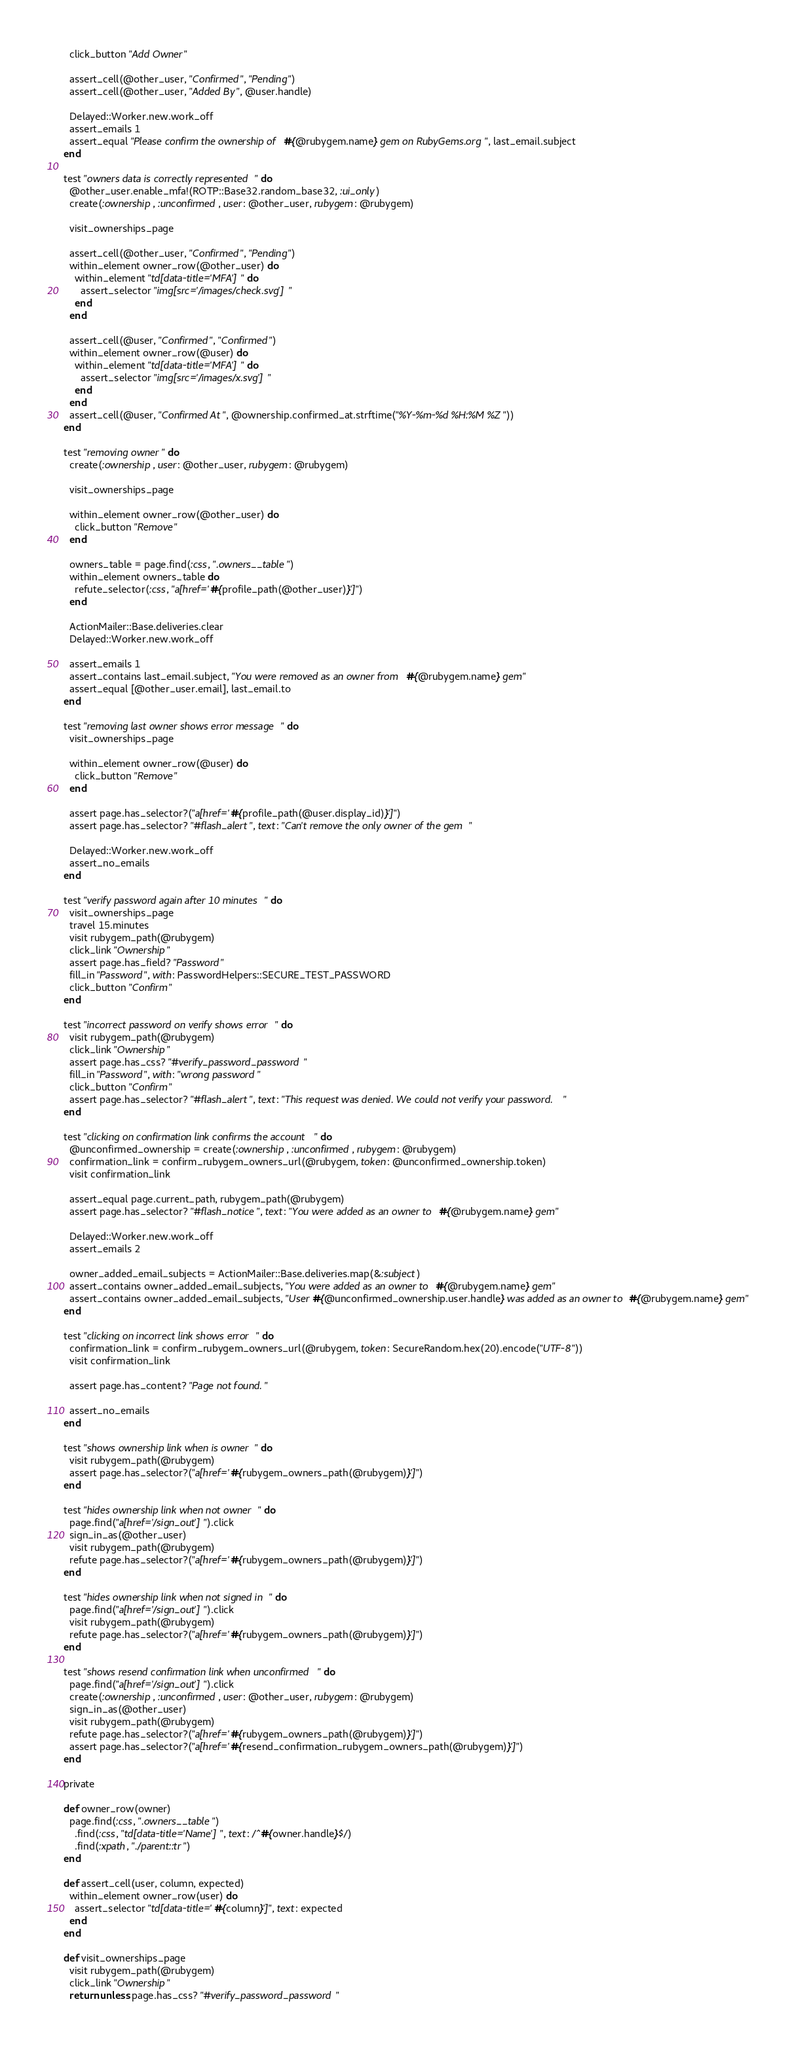<code> <loc_0><loc_0><loc_500><loc_500><_Ruby_>    click_button "Add Owner"

    assert_cell(@other_user, "Confirmed", "Pending")
    assert_cell(@other_user, "Added By", @user.handle)

    Delayed::Worker.new.work_off
    assert_emails 1
    assert_equal "Please confirm the ownership of #{@rubygem.name} gem on RubyGems.org", last_email.subject
  end

  test "owners data is correctly represented" do
    @other_user.enable_mfa!(ROTP::Base32.random_base32, :ui_only)
    create(:ownership, :unconfirmed, user: @other_user, rubygem: @rubygem)

    visit_ownerships_page

    assert_cell(@other_user, "Confirmed", "Pending")
    within_element owner_row(@other_user) do
      within_element "td[data-title='MFA']" do
        assert_selector "img[src='/images/check.svg']"
      end
    end

    assert_cell(@user, "Confirmed", "Confirmed")
    within_element owner_row(@user) do
      within_element "td[data-title='MFA']" do
        assert_selector "img[src='/images/x.svg']"
      end
    end
    assert_cell(@user, "Confirmed At", @ownership.confirmed_at.strftime("%Y-%m-%d %H:%M %Z"))
  end

  test "removing owner" do
    create(:ownership, user: @other_user, rubygem: @rubygem)

    visit_ownerships_page

    within_element owner_row(@other_user) do
      click_button "Remove"
    end

    owners_table = page.find(:css, ".owners__table")
    within_element owners_table do
      refute_selector(:css, "a[href='#{profile_path(@other_user)}']")
    end

    ActionMailer::Base.deliveries.clear
    Delayed::Worker.new.work_off

    assert_emails 1
    assert_contains last_email.subject, "You were removed as an owner from #{@rubygem.name} gem"
    assert_equal [@other_user.email], last_email.to
  end

  test "removing last owner shows error message" do
    visit_ownerships_page

    within_element owner_row(@user) do
      click_button "Remove"
    end

    assert page.has_selector?("a[href='#{profile_path(@user.display_id)}']")
    assert page.has_selector? "#flash_alert", text: "Can't remove the only owner of the gem"

    Delayed::Worker.new.work_off
    assert_no_emails
  end

  test "verify password again after 10 minutes" do
    visit_ownerships_page
    travel 15.minutes
    visit rubygem_path(@rubygem)
    click_link "Ownership"
    assert page.has_field? "Password"
    fill_in "Password", with: PasswordHelpers::SECURE_TEST_PASSWORD
    click_button "Confirm"
  end

  test "incorrect password on verify shows error" do
    visit rubygem_path(@rubygem)
    click_link "Ownership"
    assert page.has_css? "#verify_password_password"
    fill_in "Password", with: "wrong password"
    click_button "Confirm"
    assert page.has_selector? "#flash_alert", text: "This request was denied. We could not verify your password."
  end

  test "clicking on confirmation link confirms the account" do
    @unconfirmed_ownership = create(:ownership, :unconfirmed, rubygem: @rubygem)
    confirmation_link = confirm_rubygem_owners_url(@rubygem, token: @unconfirmed_ownership.token)
    visit confirmation_link

    assert_equal page.current_path, rubygem_path(@rubygem)
    assert page.has_selector? "#flash_notice", text: "You were added as an owner to #{@rubygem.name} gem"

    Delayed::Worker.new.work_off
    assert_emails 2

    owner_added_email_subjects = ActionMailer::Base.deliveries.map(&:subject)
    assert_contains owner_added_email_subjects, "You were added as an owner to #{@rubygem.name} gem"
    assert_contains owner_added_email_subjects, "User #{@unconfirmed_ownership.user.handle} was added as an owner to #{@rubygem.name} gem"
  end

  test "clicking on incorrect link shows error" do
    confirmation_link = confirm_rubygem_owners_url(@rubygem, token: SecureRandom.hex(20).encode("UTF-8"))
    visit confirmation_link

    assert page.has_content? "Page not found."

    assert_no_emails
  end

  test "shows ownership link when is owner" do
    visit rubygem_path(@rubygem)
    assert page.has_selector?("a[href='#{rubygem_owners_path(@rubygem)}']")
  end

  test "hides ownership link when not owner" do
    page.find("a[href='/sign_out']").click
    sign_in_as(@other_user)
    visit rubygem_path(@rubygem)
    refute page.has_selector?("a[href='#{rubygem_owners_path(@rubygem)}']")
  end

  test "hides ownership link when not signed in" do
    page.find("a[href='/sign_out']").click
    visit rubygem_path(@rubygem)
    refute page.has_selector?("a[href='#{rubygem_owners_path(@rubygem)}']")
  end

  test "shows resend confirmation link when unconfirmed" do
    page.find("a[href='/sign_out']").click
    create(:ownership, :unconfirmed, user: @other_user, rubygem: @rubygem)
    sign_in_as(@other_user)
    visit rubygem_path(@rubygem)
    refute page.has_selector?("a[href='#{rubygem_owners_path(@rubygem)}']")
    assert page.has_selector?("a[href='#{resend_confirmation_rubygem_owners_path(@rubygem)}']")
  end

  private

  def owner_row(owner)
    page.find(:css, ".owners__table")
      .find(:css, "td[data-title='Name']", text: /^#{owner.handle}$/)
      .find(:xpath, "./parent::tr")
  end

  def assert_cell(user, column, expected)
    within_element owner_row(user) do
      assert_selector "td[data-title='#{column}']", text: expected
    end
  end

  def visit_ownerships_page
    visit rubygem_path(@rubygem)
    click_link "Ownership"
    return unless page.has_css? "#verify_password_password"
</code> 